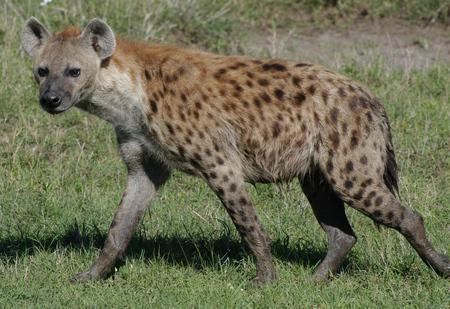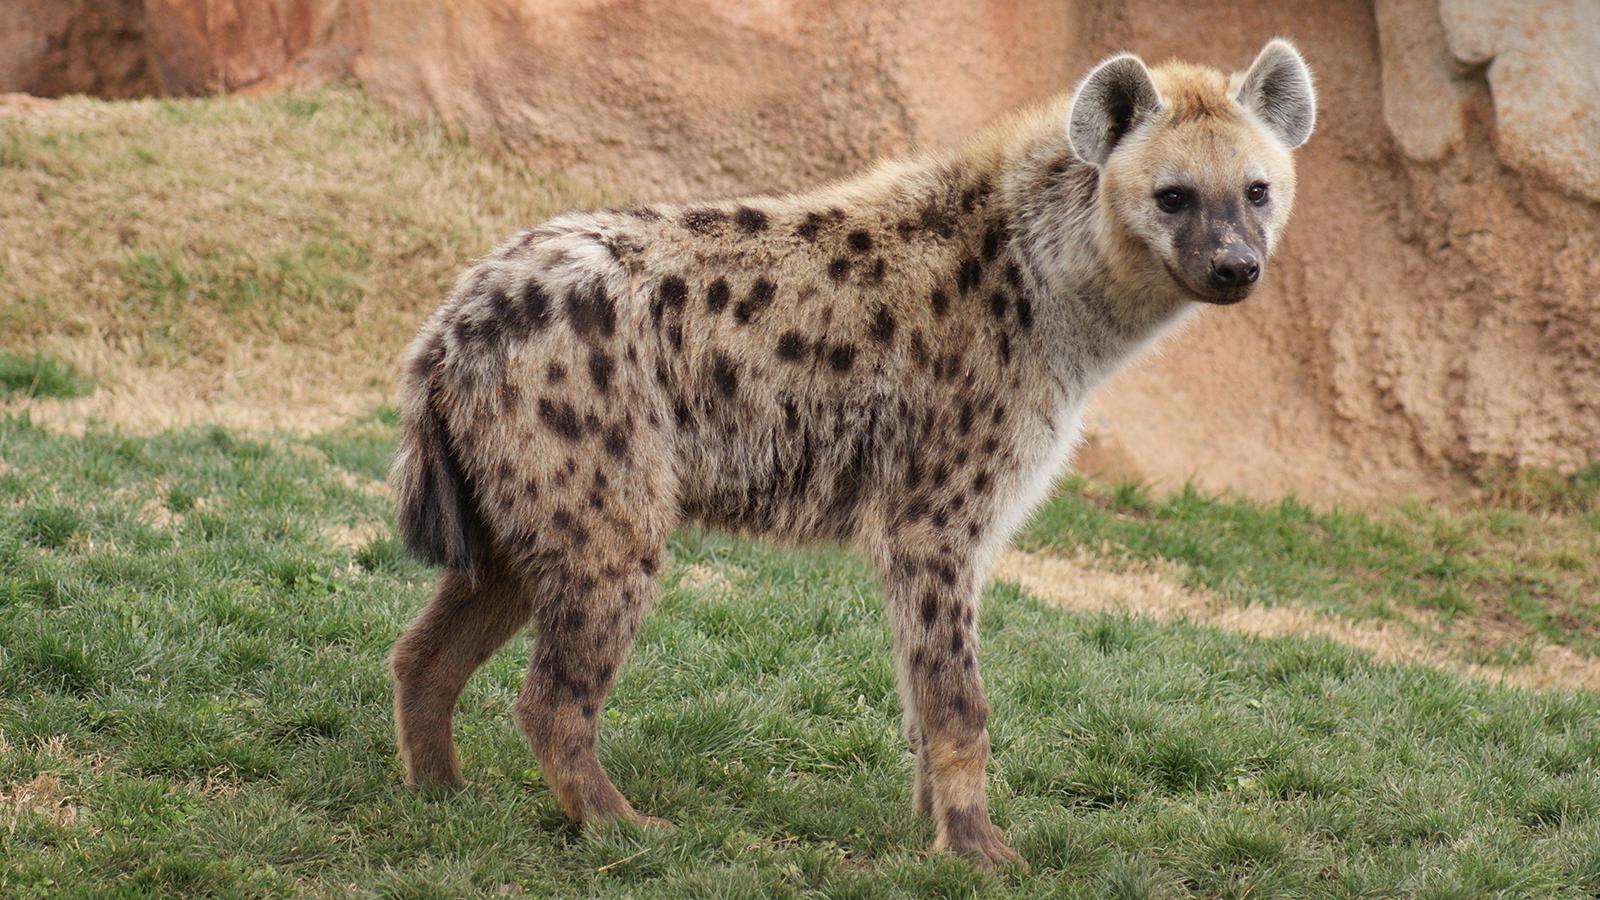The first image is the image on the left, the second image is the image on the right. Considering the images on both sides, is "There are two hyenas in a photo." valid? Answer yes or no. No. 